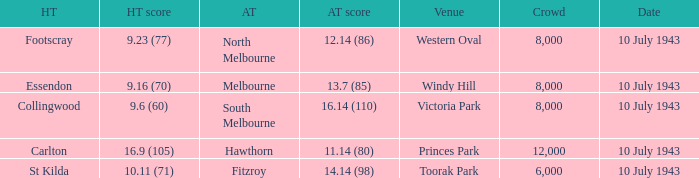When the Venue was victoria park, what was the Away team score? 16.14 (110). 